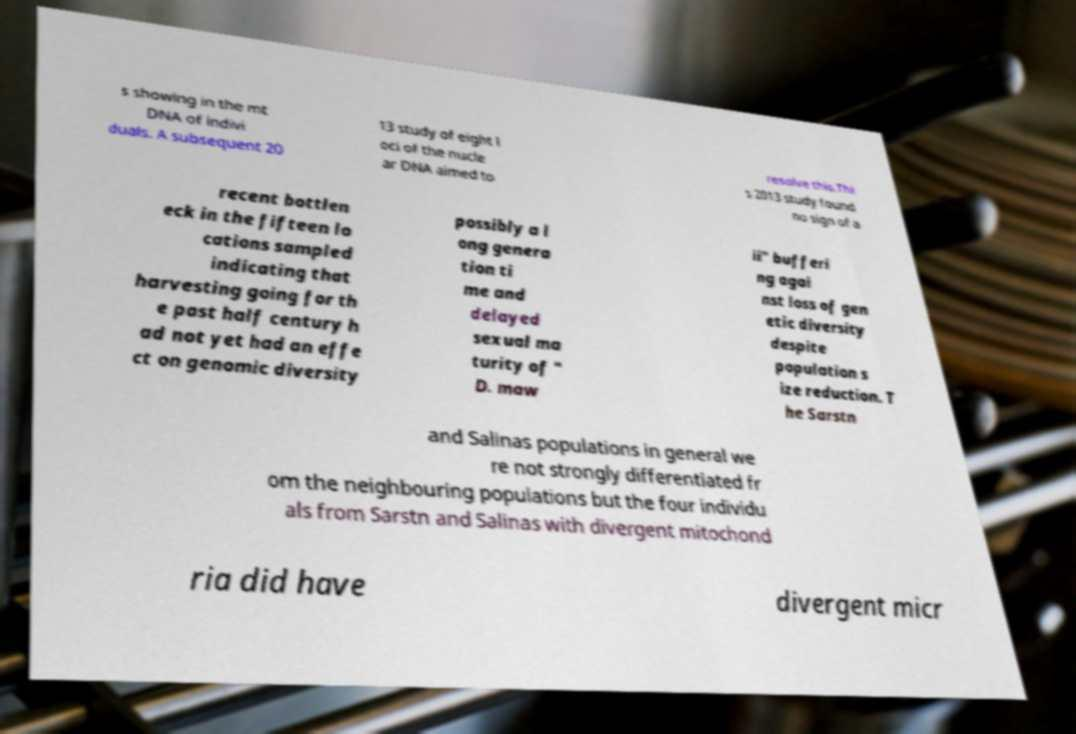There's text embedded in this image that I need extracted. Can you transcribe it verbatim? s showing in the mt DNA of indivi duals. A subsequent 20 13 study of eight l oci of the nucle ar DNA aimed to resolve this.Thi s 2013 study found no sign of a recent bottlen eck in the fifteen lo cations sampled indicating that harvesting going for th e past half century h ad not yet had an effe ct on genomic diversity possibly a l ong genera tion ti me and delayed sexual ma turity of " D. maw ii" bufferi ng agai nst loss of gen etic diversity despite population s ize reduction. T he Sarstn and Salinas populations in general we re not strongly differentiated fr om the neighbouring populations but the four individu als from Sarstn and Salinas with divergent mitochond ria did have divergent micr 